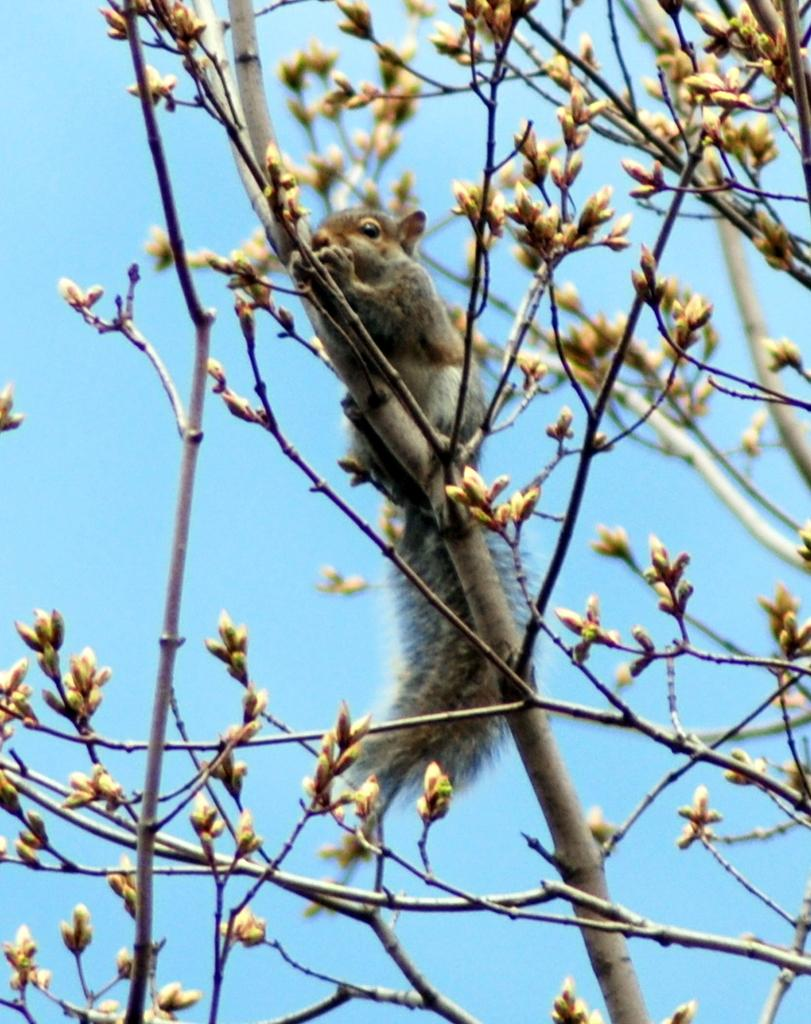What animal can be seen in the image? There is a squirrel in the image. Where is the squirrel located? The squirrel is on a tree branch. What can be seen in the background of the image? There is sky visible in the background of the image. What type of record is the squirrel holding in the image? There is no record present in the image; it features a squirrel on a tree branch with sky visible in the background. 